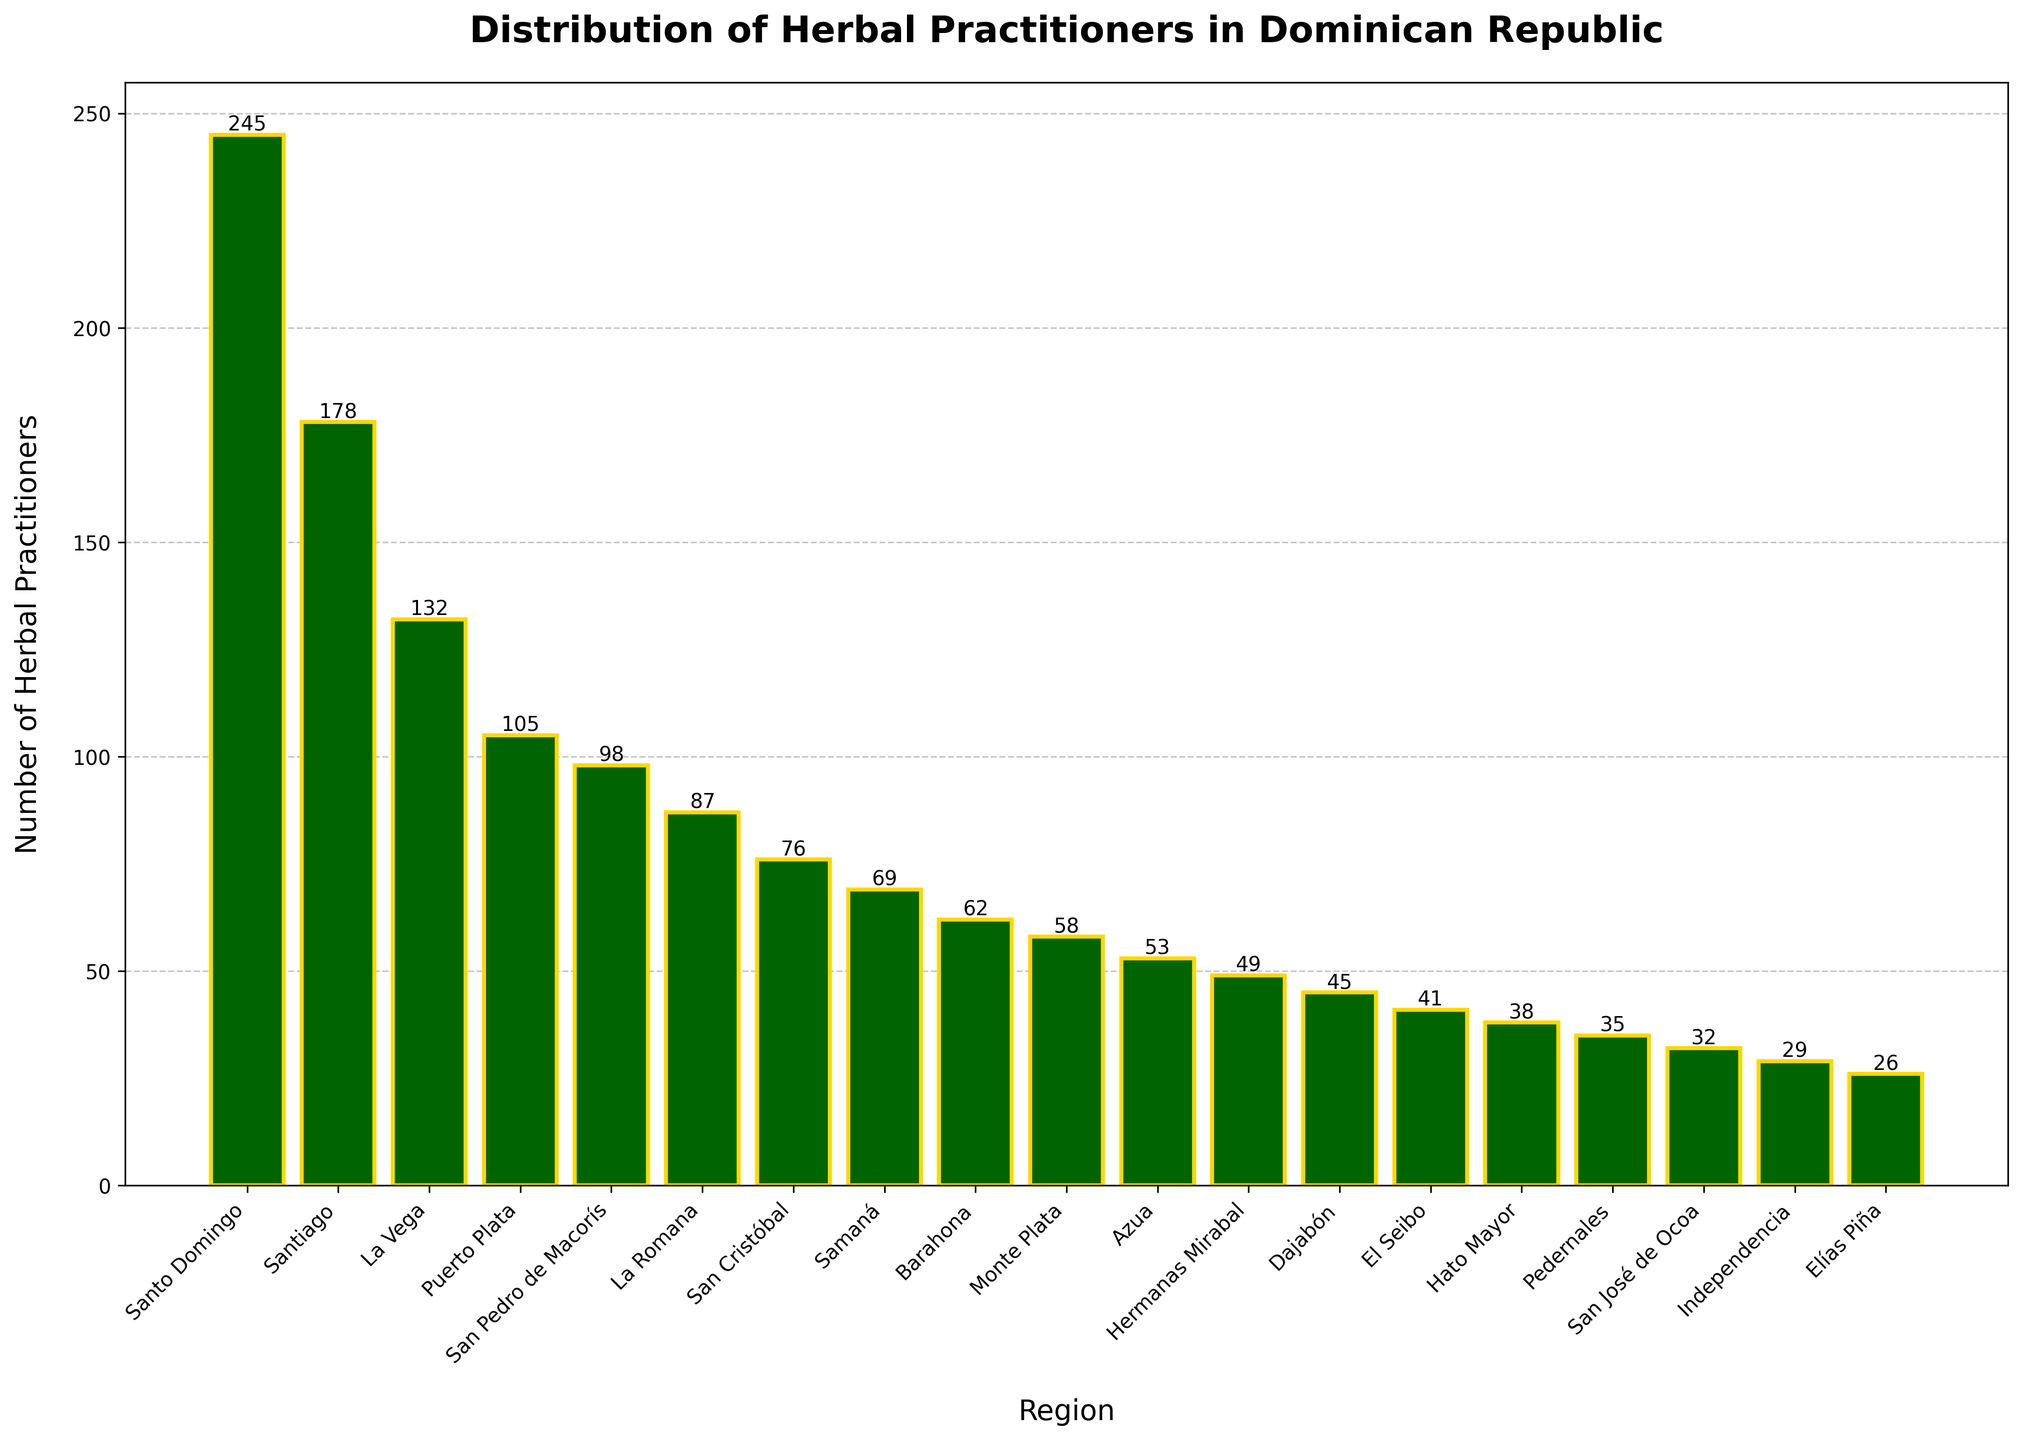Which region has the highest number of herbal practitioners? To find the region with the highest number of herbal practitioners, look for the tallest bar. In the figure, the tallest bar corresponds to Santo Domingo.
Answer: Santo Domingo Which region has the second-highest number of herbal practitioners? Look for the second tallest bar after Santo Domingo. The second tallest bar corresponds to Santiago.
Answer: Santiago How many herbal practitioners are there in total in Santiago and La Vega combined? Add the number of herbal practitioners in Santiago (178) and La Vega (132). The sum is 178 + 132 = 310.
Answer: 310 Which regions have fewer than 50 herbal practitioners? Look for bars with heights representing numbers below 50. The regions are Hermanas Mirabal, Dajabón, El Seibo, Hato Mayor, Pedernales, San José de Ocoa, Independencia, and Elías Piña.
Answer: Hermanas Mirabal, Dajabón, El Seibo, Hato Mayor, Pedernales, San José de Ocoa, Independencia, Elías Piña How many more herbal practitioners are in Santo Domingo compared to San Pedro de Macorís? Subtract the number of herbal practitioners in San Pedro de Macorís (98) from those in Santo Domingo (245). The difference is 245 - 98 = 147.
Answer: 147 What is the average number of herbal practitioners in La Romana, San Cristóbal, and Samaná? Add the number of herbal practitioners in La Romana (87), San Cristóbal (76), and Samaná (69), and then divide by 3. The sum is 87 + 76 + 69 = 232. The average is 232 / 3 ≈ 77.33.
Answer: 77.33 What is the difference between the number of herbal practitioners in the region with the highest and the region with the lowest number? Subtract the number of herbal practitioners in Elías Piña (26) from those in Santo Domingo (245). The difference is 245 - 26 = 219.
Answer: 219 How many regions have more than 100 herbal practitioners? Look for bars with heights greater than 100. The regions are Santo Domingo, Santiago, La Vega, and Puerto Plata. This accounts for 4 regions.
Answer: 4 What is the total number of herbal practitioners across all regions shown in the figure? Sum the number of herbal practitioners across all listed regions. The total is 245 + 178 + 132 + 105 + 98 + 87 + 76 + 69 + 62 + 58 + 53 + 49 + 45 + 41 + 38 + 35 + 32 + 29 + 26 = 1,458.
Answer: 1,458 